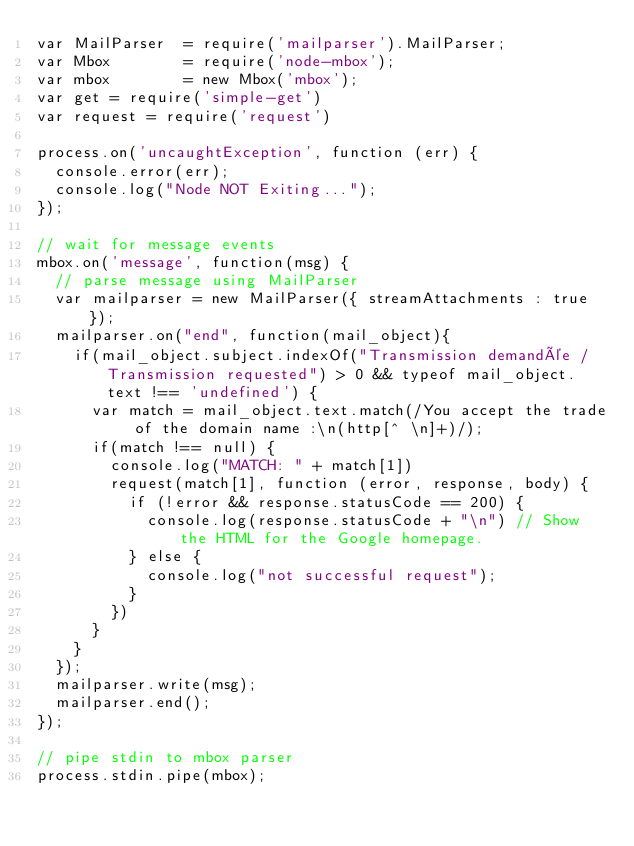<code> <loc_0><loc_0><loc_500><loc_500><_JavaScript_>var MailParser  = require('mailparser').MailParser;
var Mbox        = require('node-mbox');
var mbox        = new Mbox('mbox');
var get = require('simple-get')
var request = require('request')

process.on('uncaughtException', function (err) {
  console.error(err);
  console.log("Node NOT Exiting...");
});

// wait for message events
mbox.on('message', function(msg) {
	// parse message using MailParser
	var mailparser = new MailParser({ streamAttachments : true });
	mailparser.on("end", function(mail_object){
		if(mail_object.subject.indexOf("Transmission demandée / Transmission requested") > 0 && typeof mail_object.text !== 'undefined') {
			var match = mail_object.text.match(/You accept the trade of the domain name :\n(http[^ \n]+)/);
			if(match !== null) {
				console.log("MATCH: " + match[1])
				request(match[1], function (error, response, body) {
				  if (!error && response.statusCode == 200) {
				    console.log(response.statusCode + "\n") // Show the HTML for the Google homepage.
				  } else {
				  	console.log("not successful request");
				  }
				})
			}
		}
	});
	mailparser.write(msg);
	mailparser.end();
});

// pipe stdin to mbox parser
process.stdin.pipe(mbox);
</code> 